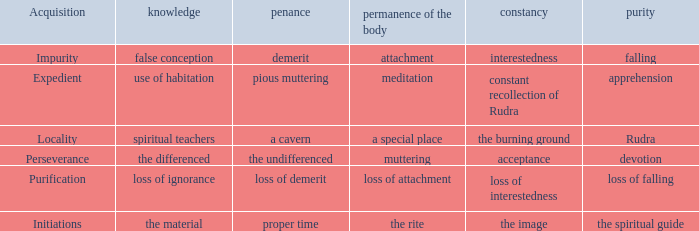What is the persistence of the body where atonement is the indistinguishable? Muttering. 